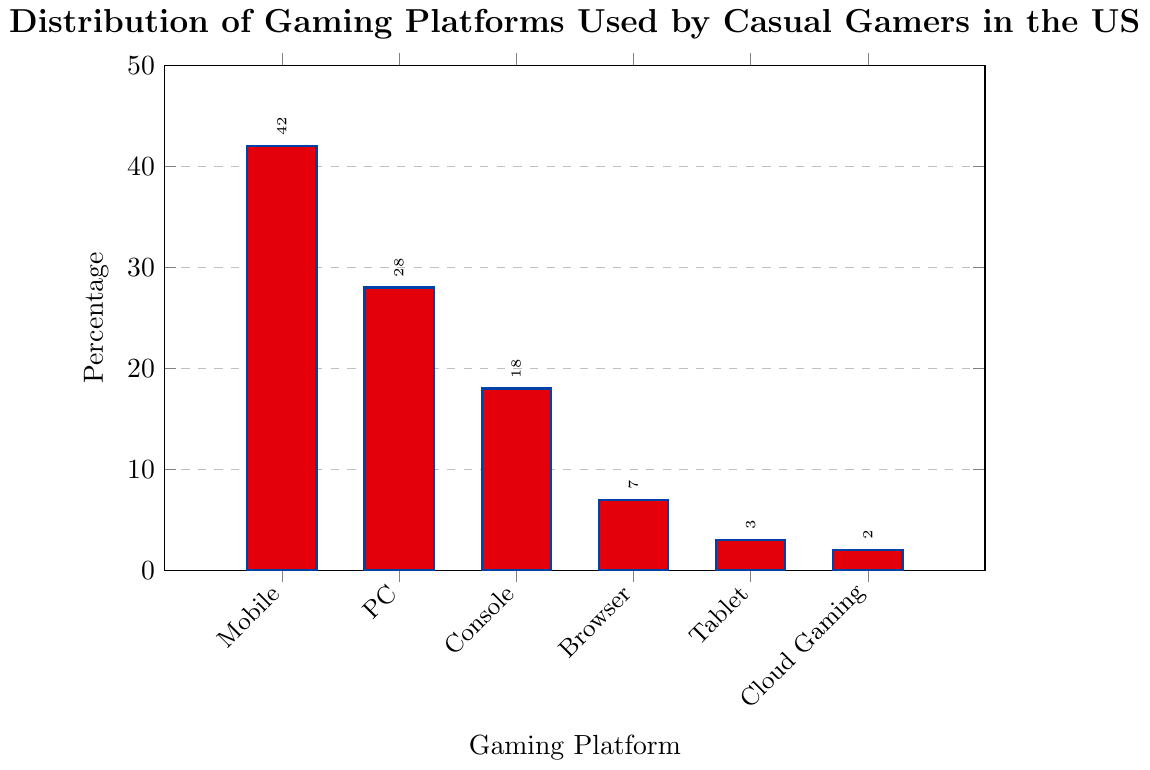What is the most popular gaming platform among casual gamers in the US? According to the figure, the gaming platform with the highest percentage is the most popular. The bar representing the "Mobile" platform is the tallest at 42%.
Answer: Mobile Which gaming platform has the lowest usage percentage among casual gamers in the US? Referring to the figure, the platform with the shortest bar will have the lowest usage percentage. The bar for "Cloud Gaming" is the shortest at 2%.
Answer: Cloud Gaming What is the combined percentage of casual gamers who play on PC and Console? To find the combined percentage, add the percentages for PC and Console. The values are 28% for PC and 18% for Console. So, 28 + 18 = 46%.
Answer: 46% Which platform has a usage percentage exactly 4 times that of Tablet? The figure shows that Tablet has a percentage of 3%. Four times this percentage is 3 * 4 = 12%. The bar for "Console" is taller at 18%, indicating no platform has exactly 12%.
Answer: None By how many percentage points does the usage of Mobile gaming surpass Console gaming among casual gamers in the US? Subtract the percentage of Console from Mobile. Mobile is at 42% and Console at 18%. So, 42 - 18 = 24 percentage points.
Answer: 24 Which two platforms together have a usage percentage closest to the percentage of Mobile gaming? Determine the percentages of two platforms that sum closest to 42%, without exceeding it. PC (28%) and Console (18%) together add to 46%, surpassing 42%. PC (28%) and Browser (7%) together add to 35%. Console (18%) and Browser (7%) together add to 25%. Browser (7%), Tablet (3%), and Cloud Gaming (2%) together add to 12%. Therefore, PC (28%) and Browser (7%) are closest at 35%.
Answer: PC and Browser How much greater is the sum of the percentages of Mobile and PC compared to the sum of Browser and Cloud Gaming? Sum of Mobile and PC is 42 + 28 = 70%. Sum of Browser and Cloud Gaming is 7 + 2 = 9%. The difference is 70 - 9 = 61 percentage points.
Answer: 61 Which platform usage shares more visual attributes (color) with Spiderman's suit? The bar colored in red represents the "Mobile" platform, which visually shares more attributes with Spiderman's suit.
Answer: Mobile 